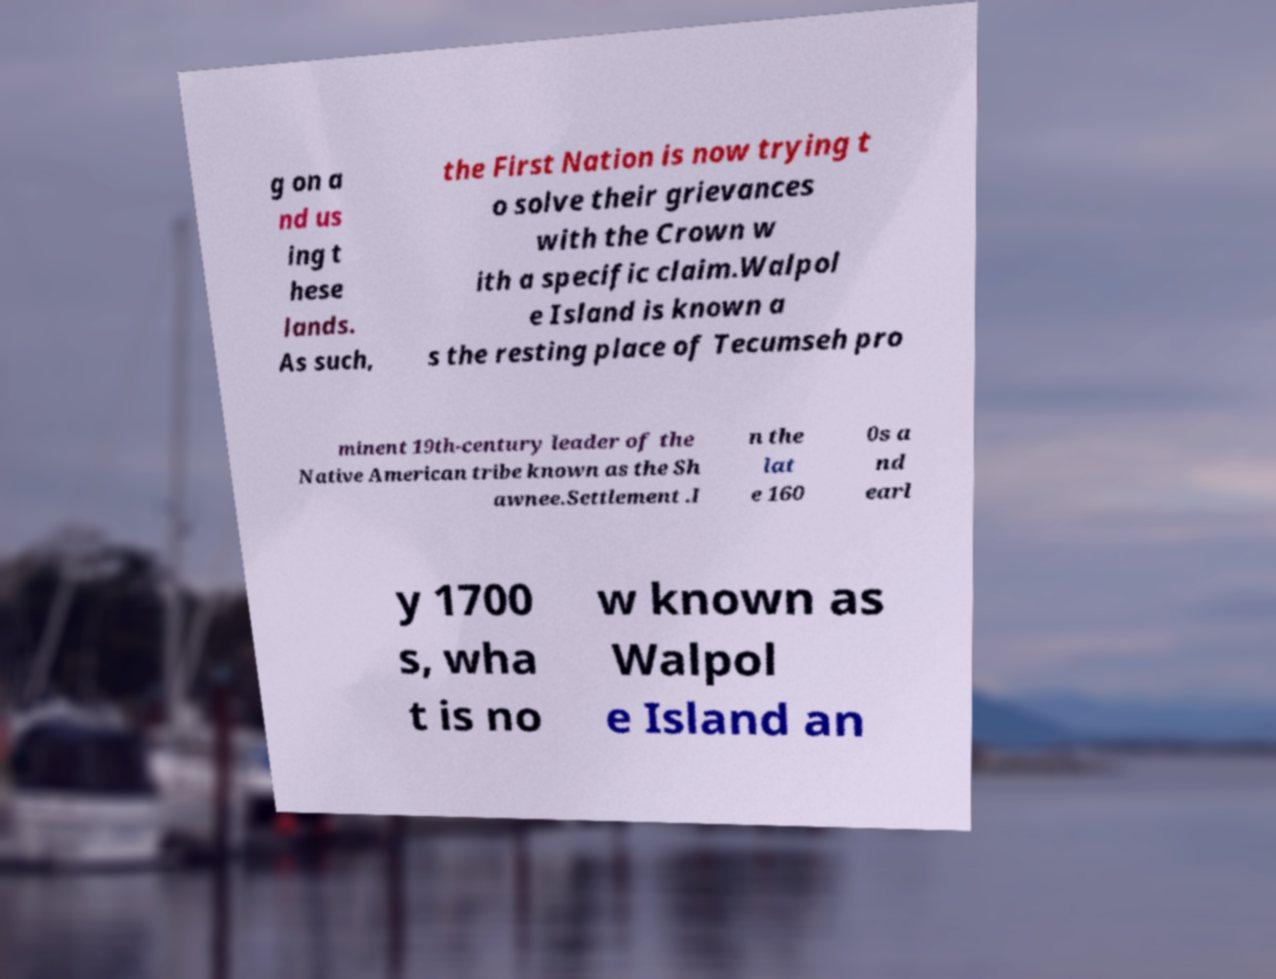There's text embedded in this image that I need extracted. Can you transcribe it verbatim? g on a nd us ing t hese lands. As such, the First Nation is now trying t o solve their grievances with the Crown w ith a specific claim.Walpol e Island is known a s the resting place of Tecumseh pro minent 19th-century leader of the Native American tribe known as the Sh awnee.Settlement .I n the lat e 160 0s a nd earl y 1700 s, wha t is no w known as Walpol e Island an 